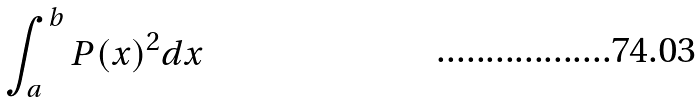<formula> <loc_0><loc_0><loc_500><loc_500>\int _ { a } ^ { b } P ( x ) ^ { 2 } d x</formula> 